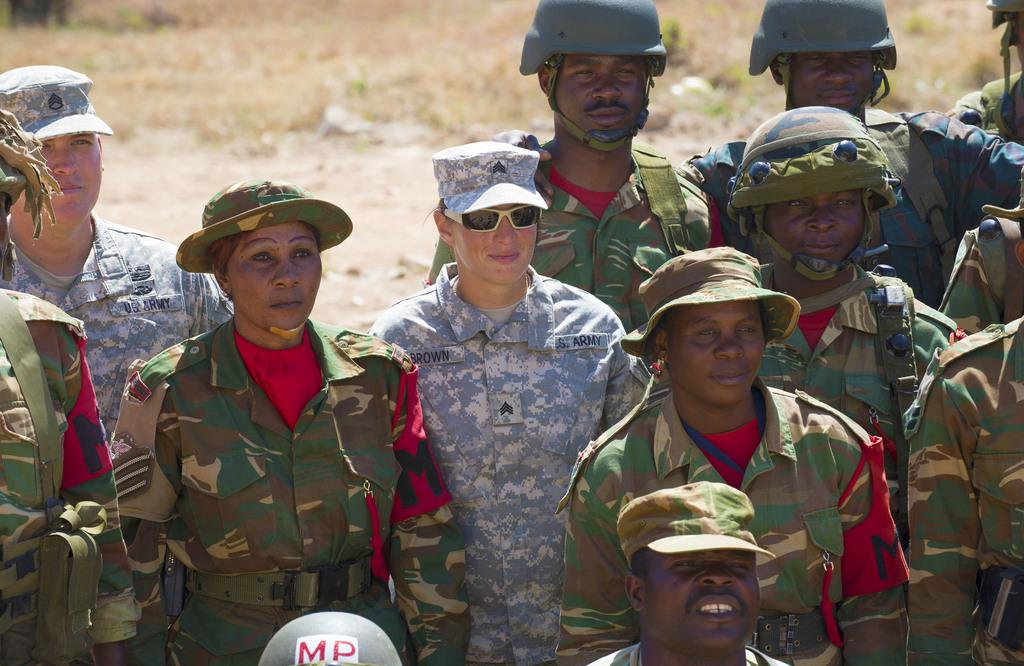What is the main subject of the image? The main subject of the image is a group of people. What are the people in the image doing? The people are standing. What are the people wearing on their heads? The people are wearing caps. What type of clothing are the people wearing? The people are wearing dresses. Can you see any fog in the image? There is no fog visible in the image. What type of drum can be heard being played in the image? There is no drum present in the image, and therefore no such sound can be heard. 